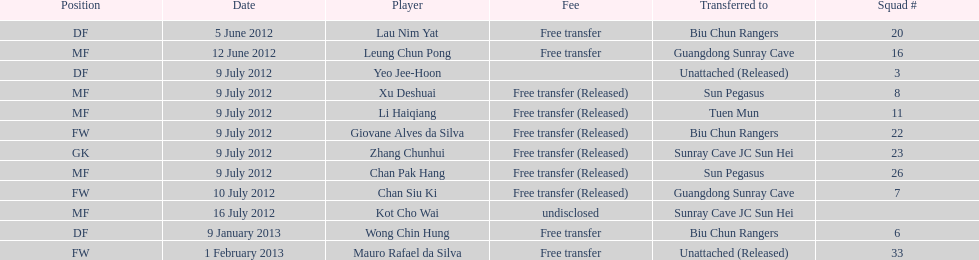How many consecutive players were released on july 9? 6. 